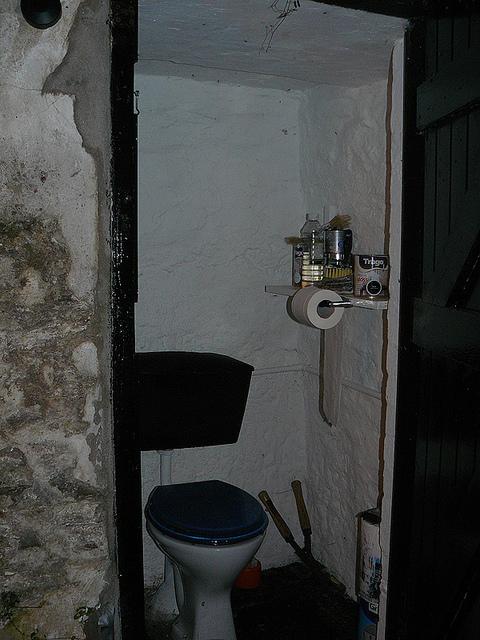Is there a reflection?
Keep it brief. No. What is reflected on the stall?
Give a very brief answer. Nothing. What color is the toilet?
Quick response, please. Black and white. How many toilets do you see?
Be succinct. 1. What color is the toilet seat?
Short answer required. Blue. Is this a stove?
Concise answer only. No. Is this a newly remodeled bathroom?
Short answer required. No. Is the toilet paper coming over the top or from the bottom?
Concise answer only. Bottom. Is this toilet operational?
Keep it brief. Yes. Is there a light in this room?
Give a very brief answer. No. Does the toilet function properly?
Concise answer only. Yes. What is the light for?
Concise answer only. Bathroom. Are you able to watch yourself poop?
Keep it brief. No. What color is the toilet tank?
Concise answer only. Black. Is the toilet paper higher than usual?
Write a very short answer. Yes. Is this a normal location for a toilet?
Answer briefly. Yes. 